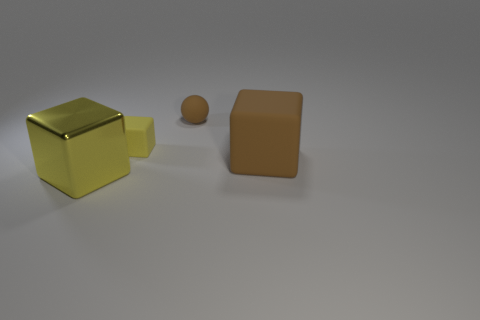Subtract all yellow cubes. How many cubes are left? 1 Add 4 yellow metal things. How many objects exist? 8 Subtract 2 blocks. How many blocks are left? 1 Subtract all yellow spheres. How many red blocks are left? 0 Subtract all large blue matte cubes. Subtract all small spheres. How many objects are left? 3 Add 3 matte objects. How many matte objects are left? 6 Add 2 big matte objects. How many big matte objects exist? 3 Subtract all brown blocks. How many blocks are left? 2 Subtract 0 yellow cylinders. How many objects are left? 4 Subtract all balls. How many objects are left? 3 